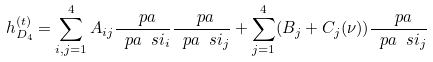<formula> <loc_0><loc_0><loc_500><loc_500>h ^ { ( t ) } _ { D _ { 4 } } = \sum _ { i , j = 1 } ^ { 4 } A _ { i j } \frac { \ p a } { \ p a \ s i _ { i } } \frac { \ p a } { \ p a \ s i _ { j } } + \sum _ { j = 1 } ^ { 4 } ( B _ { j } + C _ { j } ( \nu ) ) \frac { \ p a } { \ p a \ s i _ { j } }</formula> 